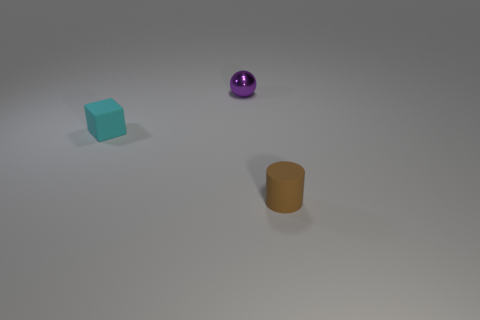Is there anything else that has the same material as the small purple object?
Give a very brief answer. No. There is a brown matte object that is in front of the purple thing; is its size the same as the cyan rubber thing?
Offer a very short reply. Yes. How big is the object that is behind the small rubber cylinder and on the right side of the cube?
Provide a short and direct response. Small. How many other objects are there of the same material as the small purple sphere?
Ensure brevity in your answer.  0. There is a thing that is in front of the tiny cyan thing; how big is it?
Keep it short and to the point. Small. Is the color of the small sphere the same as the tiny matte cube?
Make the answer very short. No. What number of small objects are either matte cylinders or purple matte objects?
Make the answer very short. 1. Is there any other thing of the same color as the tiny ball?
Your answer should be very brief. No. There is a brown thing; are there any tiny metal spheres in front of it?
Give a very brief answer. No. How big is the rubber thing left of the tiny rubber object right of the metal thing?
Ensure brevity in your answer.  Small. 